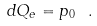<formula> <loc_0><loc_0><loc_500><loc_500>d Q _ { e } = p _ { 0 } \ .</formula> 